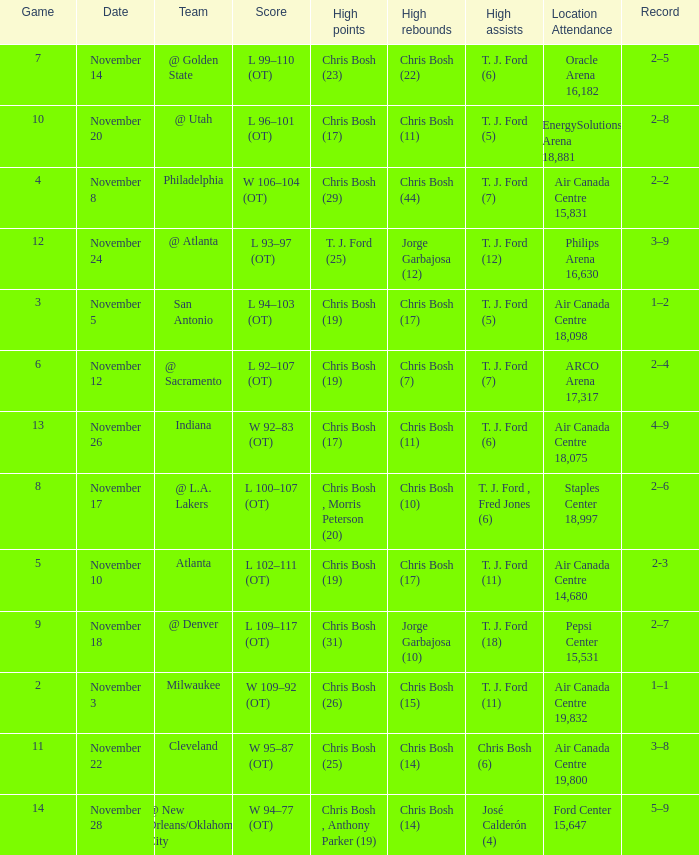Where was the game on November 20? EnergySolutions Arena 18,881. 